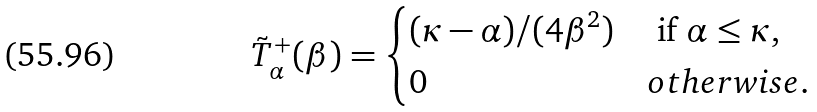Convert formula to latex. <formula><loc_0><loc_0><loc_500><loc_500>\tilde { T } ^ { + } _ { \alpha } ( \beta ) = \begin{cases} ( \kappa - \alpha ) / ( 4 \beta ^ { 2 } ) & \text { if } \alpha \leq \kappa , \\ 0 & o t h e r w i s e . \end{cases}</formula> 